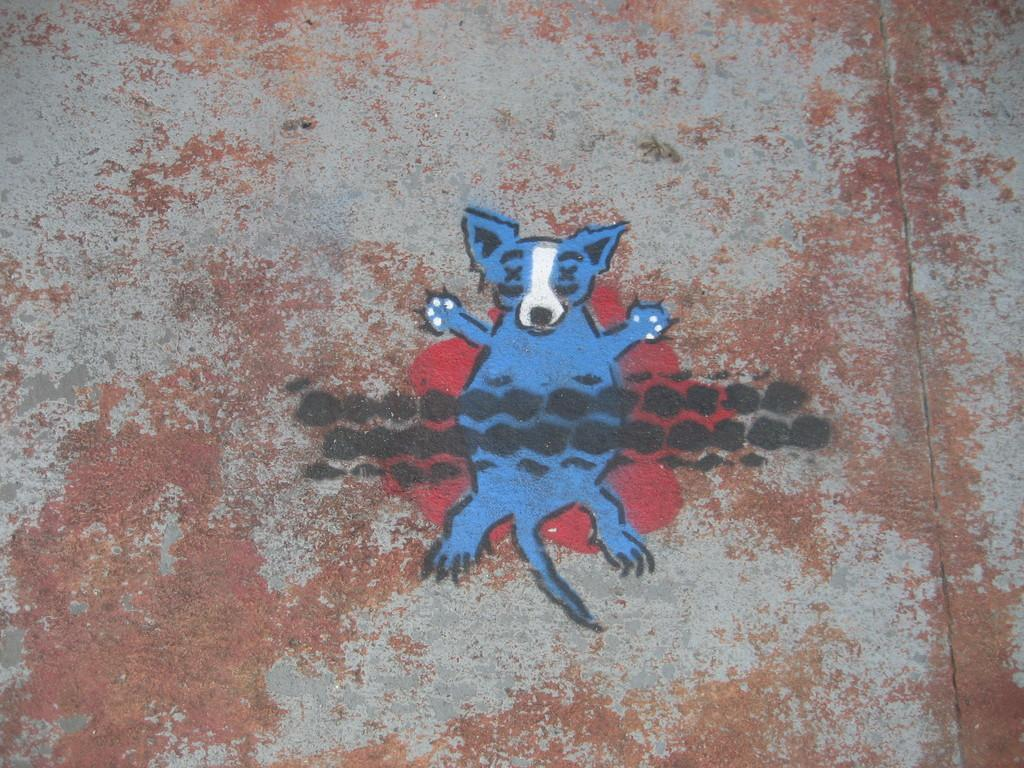What is the main subject of the image? There is a painting in the image. What is depicted in the painting? The painting depicts an animal. Can you describe the appearance of the animal in the painting? The animal has black and red marks in the painting. How many forks are used to exchange information between the animals in the painting? There are no forks or exchange of information between animals in the painting; it is a static image of an animal with black and red marks. 